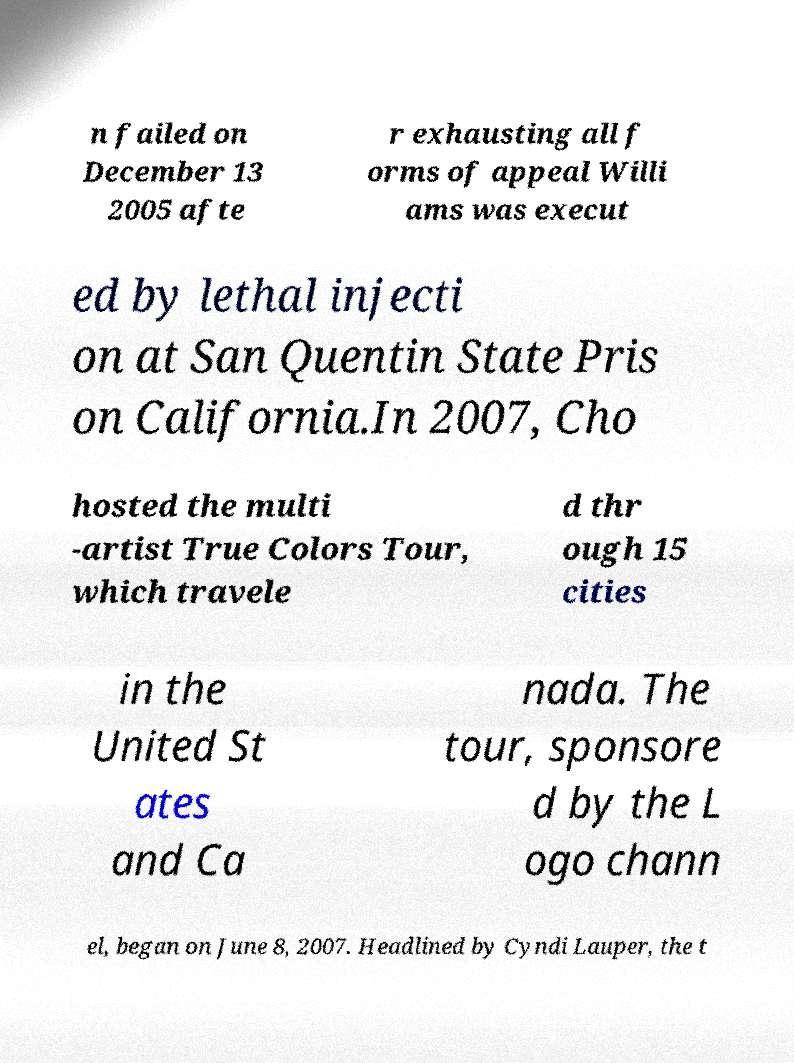Could you extract and type out the text from this image? n failed on December 13 2005 afte r exhausting all f orms of appeal Willi ams was execut ed by lethal injecti on at San Quentin State Pris on California.In 2007, Cho hosted the multi -artist True Colors Tour, which travele d thr ough 15 cities in the United St ates and Ca nada. The tour, sponsore d by the L ogo chann el, began on June 8, 2007. Headlined by Cyndi Lauper, the t 